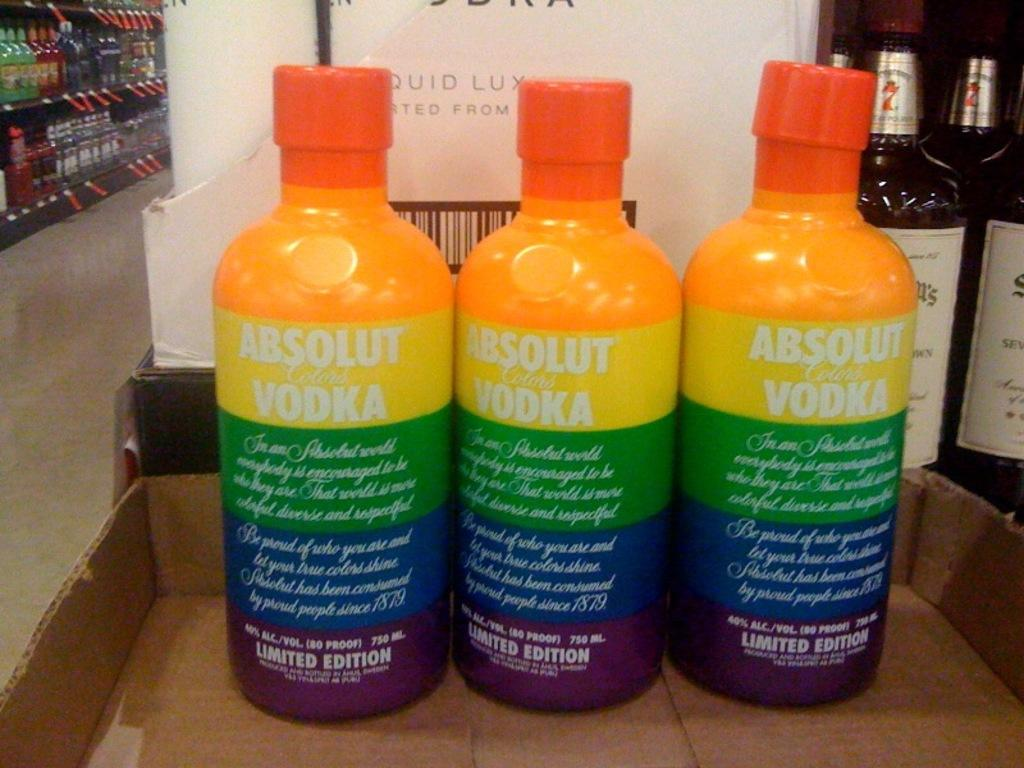<image>
Present a compact description of the photo's key features. Three bottles of Absolut Vodka have rainbow colored patterns. 